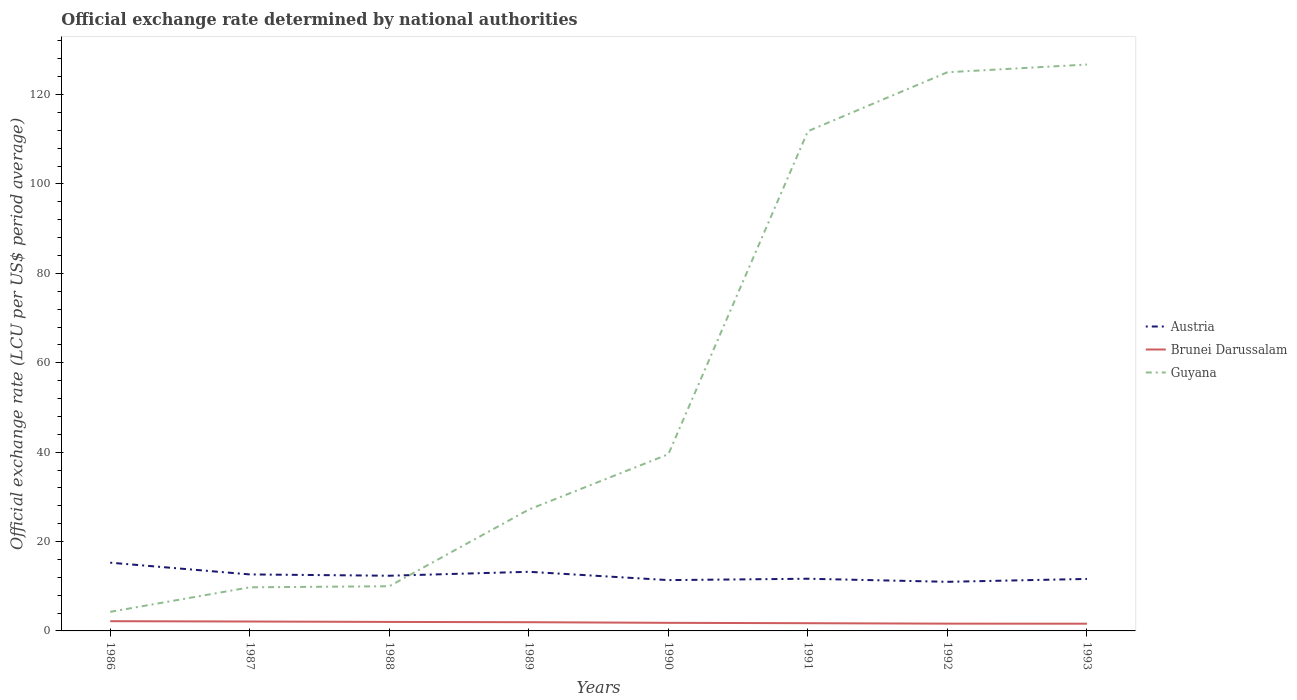Is the number of lines equal to the number of legend labels?
Offer a terse response. Yes. Across all years, what is the maximum official exchange rate in Brunei Darussalam?
Offer a very short reply. 1.62. In which year was the official exchange rate in Austria maximum?
Offer a very short reply. 1992. What is the total official exchange rate in Guyana in the graph?
Offer a very short reply. -14.92. What is the difference between the highest and the second highest official exchange rate in Austria?
Ensure brevity in your answer.  4.28. Is the official exchange rate in Brunei Darussalam strictly greater than the official exchange rate in Guyana over the years?
Offer a terse response. Yes. How many lines are there?
Your answer should be compact. 3. How many years are there in the graph?
Provide a short and direct response. 8. Are the values on the major ticks of Y-axis written in scientific E-notation?
Offer a terse response. No. What is the title of the graph?
Make the answer very short. Official exchange rate determined by national authorities. Does "Senegal" appear as one of the legend labels in the graph?
Offer a very short reply. No. What is the label or title of the X-axis?
Your answer should be compact. Years. What is the label or title of the Y-axis?
Provide a short and direct response. Official exchange rate (LCU per US$ period average). What is the Official exchange rate (LCU per US$ period average) in Austria in 1986?
Your answer should be very brief. 15.27. What is the Official exchange rate (LCU per US$ period average) of Brunei Darussalam in 1986?
Your answer should be compact. 2.18. What is the Official exchange rate (LCU per US$ period average) of Guyana in 1986?
Offer a terse response. 4.27. What is the Official exchange rate (LCU per US$ period average) in Austria in 1987?
Offer a very short reply. 12.64. What is the Official exchange rate (LCU per US$ period average) of Brunei Darussalam in 1987?
Keep it short and to the point. 2.11. What is the Official exchange rate (LCU per US$ period average) of Guyana in 1987?
Provide a succinct answer. 9.76. What is the Official exchange rate (LCU per US$ period average) in Austria in 1988?
Ensure brevity in your answer.  12.35. What is the Official exchange rate (LCU per US$ period average) of Brunei Darussalam in 1988?
Offer a very short reply. 2.01. What is the Official exchange rate (LCU per US$ period average) of Guyana in 1988?
Keep it short and to the point. 10. What is the Official exchange rate (LCU per US$ period average) in Austria in 1989?
Your answer should be compact. 13.23. What is the Official exchange rate (LCU per US$ period average) in Brunei Darussalam in 1989?
Your answer should be very brief. 1.95. What is the Official exchange rate (LCU per US$ period average) in Guyana in 1989?
Keep it short and to the point. 27.16. What is the Official exchange rate (LCU per US$ period average) of Austria in 1990?
Offer a terse response. 11.37. What is the Official exchange rate (LCU per US$ period average) of Brunei Darussalam in 1990?
Offer a very short reply. 1.81. What is the Official exchange rate (LCU per US$ period average) in Guyana in 1990?
Offer a very short reply. 39.53. What is the Official exchange rate (LCU per US$ period average) of Austria in 1991?
Your answer should be very brief. 11.68. What is the Official exchange rate (LCU per US$ period average) of Brunei Darussalam in 1991?
Give a very brief answer. 1.73. What is the Official exchange rate (LCU per US$ period average) in Guyana in 1991?
Make the answer very short. 111.81. What is the Official exchange rate (LCU per US$ period average) of Austria in 1992?
Ensure brevity in your answer.  10.99. What is the Official exchange rate (LCU per US$ period average) of Brunei Darussalam in 1992?
Offer a very short reply. 1.63. What is the Official exchange rate (LCU per US$ period average) in Guyana in 1992?
Offer a terse response. 125. What is the Official exchange rate (LCU per US$ period average) of Austria in 1993?
Make the answer very short. 11.63. What is the Official exchange rate (LCU per US$ period average) in Brunei Darussalam in 1993?
Keep it short and to the point. 1.62. What is the Official exchange rate (LCU per US$ period average) of Guyana in 1993?
Your answer should be compact. 126.73. Across all years, what is the maximum Official exchange rate (LCU per US$ period average) of Austria?
Offer a terse response. 15.27. Across all years, what is the maximum Official exchange rate (LCU per US$ period average) in Brunei Darussalam?
Give a very brief answer. 2.18. Across all years, what is the maximum Official exchange rate (LCU per US$ period average) of Guyana?
Offer a very short reply. 126.73. Across all years, what is the minimum Official exchange rate (LCU per US$ period average) in Austria?
Provide a short and direct response. 10.99. Across all years, what is the minimum Official exchange rate (LCU per US$ period average) in Brunei Darussalam?
Your answer should be very brief. 1.62. Across all years, what is the minimum Official exchange rate (LCU per US$ period average) of Guyana?
Keep it short and to the point. 4.27. What is the total Official exchange rate (LCU per US$ period average) in Austria in the graph?
Ensure brevity in your answer.  99.16. What is the total Official exchange rate (LCU per US$ period average) of Brunei Darussalam in the graph?
Provide a succinct answer. 15.03. What is the total Official exchange rate (LCU per US$ period average) in Guyana in the graph?
Offer a terse response. 454.26. What is the difference between the Official exchange rate (LCU per US$ period average) of Austria in 1986 and that in 1987?
Give a very brief answer. 2.62. What is the difference between the Official exchange rate (LCU per US$ period average) in Brunei Darussalam in 1986 and that in 1987?
Give a very brief answer. 0.07. What is the difference between the Official exchange rate (LCU per US$ period average) of Guyana in 1986 and that in 1987?
Provide a short and direct response. -5.48. What is the difference between the Official exchange rate (LCU per US$ period average) in Austria in 1986 and that in 1988?
Offer a very short reply. 2.92. What is the difference between the Official exchange rate (LCU per US$ period average) of Brunei Darussalam in 1986 and that in 1988?
Provide a short and direct response. 0.17. What is the difference between the Official exchange rate (LCU per US$ period average) of Guyana in 1986 and that in 1988?
Ensure brevity in your answer.  -5.73. What is the difference between the Official exchange rate (LCU per US$ period average) of Austria in 1986 and that in 1989?
Give a very brief answer. 2.04. What is the difference between the Official exchange rate (LCU per US$ period average) in Brunei Darussalam in 1986 and that in 1989?
Offer a very short reply. 0.23. What is the difference between the Official exchange rate (LCU per US$ period average) in Guyana in 1986 and that in 1989?
Ensure brevity in your answer.  -22.89. What is the difference between the Official exchange rate (LCU per US$ period average) of Austria in 1986 and that in 1990?
Your answer should be compact. 3.9. What is the difference between the Official exchange rate (LCU per US$ period average) of Brunei Darussalam in 1986 and that in 1990?
Provide a succinct answer. 0.36. What is the difference between the Official exchange rate (LCU per US$ period average) of Guyana in 1986 and that in 1990?
Provide a short and direct response. -35.26. What is the difference between the Official exchange rate (LCU per US$ period average) in Austria in 1986 and that in 1991?
Your response must be concise. 3.59. What is the difference between the Official exchange rate (LCU per US$ period average) in Brunei Darussalam in 1986 and that in 1991?
Offer a very short reply. 0.45. What is the difference between the Official exchange rate (LCU per US$ period average) in Guyana in 1986 and that in 1991?
Keep it short and to the point. -107.54. What is the difference between the Official exchange rate (LCU per US$ period average) of Austria in 1986 and that in 1992?
Offer a terse response. 4.28. What is the difference between the Official exchange rate (LCU per US$ period average) in Brunei Darussalam in 1986 and that in 1992?
Ensure brevity in your answer.  0.55. What is the difference between the Official exchange rate (LCU per US$ period average) in Guyana in 1986 and that in 1992?
Your response must be concise. -120.73. What is the difference between the Official exchange rate (LCU per US$ period average) in Austria in 1986 and that in 1993?
Offer a terse response. 3.63. What is the difference between the Official exchange rate (LCU per US$ period average) in Brunei Darussalam in 1986 and that in 1993?
Offer a terse response. 0.56. What is the difference between the Official exchange rate (LCU per US$ period average) in Guyana in 1986 and that in 1993?
Your response must be concise. -122.46. What is the difference between the Official exchange rate (LCU per US$ period average) in Austria in 1987 and that in 1988?
Provide a succinct answer. 0.29. What is the difference between the Official exchange rate (LCU per US$ period average) of Brunei Darussalam in 1987 and that in 1988?
Provide a short and direct response. 0.09. What is the difference between the Official exchange rate (LCU per US$ period average) in Guyana in 1987 and that in 1988?
Offer a terse response. -0.24. What is the difference between the Official exchange rate (LCU per US$ period average) of Austria in 1987 and that in 1989?
Ensure brevity in your answer.  -0.59. What is the difference between the Official exchange rate (LCU per US$ period average) of Brunei Darussalam in 1987 and that in 1989?
Your answer should be compact. 0.16. What is the difference between the Official exchange rate (LCU per US$ period average) in Guyana in 1987 and that in 1989?
Your answer should be very brief. -17.4. What is the difference between the Official exchange rate (LCU per US$ period average) of Austria in 1987 and that in 1990?
Make the answer very short. 1.27. What is the difference between the Official exchange rate (LCU per US$ period average) in Brunei Darussalam in 1987 and that in 1990?
Give a very brief answer. 0.29. What is the difference between the Official exchange rate (LCU per US$ period average) in Guyana in 1987 and that in 1990?
Offer a terse response. -29.78. What is the difference between the Official exchange rate (LCU per US$ period average) of Austria in 1987 and that in 1991?
Ensure brevity in your answer.  0.97. What is the difference between the Official exchange rate (LCU per US$ period average) in Brunei Darussalam in 1987 and that in 1991?
Your answer should be compact. 0.38. What is the difference between the Official exchange rate (LCU per US$ period average) in Guyana in 1987 and that in 1991?
Your answer should be very brief. -102.05. What is the difference between the Official exchange rate (LCU per US$ period average) of Austria in 1987 and that in 1992?
Provide a succinct answer. 1.65. What is the difference between the Official exchange rate (LCU per US$ period average) in Brunei Darussalam in 1987 and that in 1992?
Offer a terse response. 0.48. What is the difference between the Official exchange rate (LCU per US$ period average) in Guyana in 1987 and that in 1992?
Ensure brevity in your answer.  -115.25. What is the difference between the Official exchange rate (LCU per US$ period average) in Austria in 1987 and that in 1993?
Provide a succinct answer. 1.01. What is the difference between the Official exchange rate (LCU per US$ period average) of Brunei Darussalam in 1987 and that in 1993?
Give a very brief answer. 0.49. What is the difference between the Official exchange rate (LCU per US$ period average) of Guyana in 1987 and that in 1993?
Offer a terse response. -116.97. What is the difference between the Official exchange rate (LCU per US$ period average) of Austria in 1988 and that in 1989?
Offer a very short reply. -0.88. What is the difference between the Official exchange rate (LCU per US$ period average) of Brunei Darussalam in 1988 and that in 1989?
Your answer should be compact. 0.06. What is the difference between the Official exchange rate (LCU per US$ period average) of Guyana in 1988 and that in 1989?
Offer a very short reply. -17.16. What is the difference between the Official exchange rate (LCU per US$ period average) of Austria in 1988 and that in 1990?
Your answer should be compact. 0.98. What is the difference between the Official exchange rate (LCU per US$ period average) of Brunei Darussalam in 1988 and that in 1990?
Offer a very short reply. 0.2. What is the difference between the Official exchange rate (LCU per US$ period average) of Guyana in 1988 and that in 1990?
Provide a succinct answer. -29.53. What is the difference between the Official exchange rate (LCU per US$ period average) in Austria in 1988 and that in 1991?
Your response must be concise. 0.67. What is the difference between the Official exchange rate (LCU per US$ period average) in Brunei Darussalam in 1988 and that in 1991?
Your answer should be compact. 0.28. What is the difference between the Official exchange rate (LCU per US$ period average) in Guyana in 1988 and that in 1991?
Make the answer very short. -101.81. What is the difference between the Official exchange rate (LCU per US$ period average) in Austria in 1988 and that in 1992?
Your answer should be very brief. 1.36. What is the difference between the Official exchange rate (LCU per US$ period average) in Brunei Darussalam in 1988 and that in 1992?
Your response must be concise. 0.38. What is the difference between the Official exchange rate (LCU per US$ period average) in Guyana in 1988 and that in 1992?
Give a very brief answer. -115. What is the difference between the Official exchange rate (LCU per US$ period average) in Austria in 1988 and that in 1993?
Keep it short and to the point. 0.72. What is the difference between the Official exchange rate (LCU per US$ period average) in Brunei Darussalam in 1988 and that in 1993?
Make the answer very short. 0.4. What is the difference between the Official exchange rate (LCU per US$ period average) of Guyana in 1988 and that in 1993?
Provide a short and direct response. -116.73. What is the difference between the Official exchange rate (LCU per US$ period average) in Austria in 1989 and that in 1990?
Your answer should be compact. 1.86. What is the difference between the Official exchange rate (LCU per US$ period average) in Brunei Darussalam in 1989 and that in 1990?
Provide a short and direct response. 0.14. What is the difference between the Official exchange rate (LCU per US$ period average) of Guyana in 1989 and that in 1990?
Keep it short and to the point. -12.37. What is the difference between the Official exchange rate (LCU per US$ period average) in Austria in 1989 and that in 1991?
Keep it short and to the point. 1.55. What is the difference between the Official exchange rate (LCU per US$ period average) of Brunei Darussalam in 1989 and that in 1991?
Make the answer very short. 0.22. What is the difference between the Official exchange rate (LCU per US$ period average) in Guyana in 1989 and that in 1991?
Offer a terse response. -84.65. What is the difference between the Official exchange rate (LCU per US$ period average) in Austria in 1989 and that in 1992?
Your response must be concise. 2.24. What is the difference between the Official exchange rate (LCU per US$ period average) of Brunei Darussalam in 1989 and that in 1992?
Keep it short and to the point. 0.32. What is the difference between the Official exchange rate (LCU per US$ period average) of Guyana in 1989 and that in 1992?
Your answer should be very brief. -97.84. What is the difference between the Official exchange rate (LCU per US$ period average) of Austria in 1989 and that in 1993?
Offer a very short reply. 1.6. What is the difference between the Official exchange rate (LCU per US$ period average) in Brunei Darussalam in 1989 and that in 1993?
Ensure brevity in your answer.  0.33. What is the difference between the Official exchange rate (LCU per US$ period average) of Guyana in 1989 and that in 1993?
Your answer should be compact. -99.57. What is the difference between the Official exchange rate (LCU per US$ period average) in Austria in 1990 and that in 1991?
Provide a succinct answer. -0.31. What is the difference between the Official exchange rate (LCU per US$ period average) of Brunei Darussalam in 1990 and that in 1991?
Your answer should be very brief. 0.09. What is the difference between the Official exchange rate (LCU per US$ period average) in Guyana in 1990 and that in 1991?
Offer a very short reply. -72.28. What is the difference between the Official exchange rate (LCU per US$ period average) of Austria in 1990 and that in 1992?
Your response must be concise. 0.38. What is the difference between the Official exchange rate (LCU per US$ period average) in Brunei Darussalam in 1990 and that in 1992?
Provide a short and direct response. 0.18. What is the difference between the Official exchange rate (LCU per US$ period average) in Guyana in 1990 and that in 1992?
Offer a very short reply. -85.47. What is the difference between the Official exchange rate (LCU per US$ period average) in Austria in 1990 and that in 1993?
Your answer should be very brief. -0.26. What is the difference between the Official exchange rate (LCU per US$ period average) in Brunei Darussalam in 1990 and that in 1993?
Give a very brief answer. 0.2. What is the difference between the Official exchange rate (LCU per US$ period average) in Guyana in 1990 and that in 1993?
Offer a very short reply. -87.2. What is the difference between the Official exchange rate (LCU per US$ period average) in Austria in 1991 and that in 1992?
Your answer should be very brief. 0.69. What is the difference between the Official exchange rate (LCU per US$ period average) of Brunei Darussalam in 1991 and that in 1992?
Keep it short and to the point. 0.1. What is the difference between the Official exchange rate (LCU per US$ period average) in Guyana in 1991 and that in 1992?
Your answer should be compact. -13.19. What is the difference between the Official exchange rate (LCU per US$ period average) in Austria in 1991 and that in 1993?
Ensure brevity in your answer.  0.04. What is the difference between the Official exchange rate (LCU per US$ period average) of Brunei Darussalam in 1991 and that in 1993?
Ensure brevity in your answer.  0.11. What is the difference between the Official exchange rate (LCU per US$ period average) in Guyana in 1991 and that in 1993?
Make the answer very short. -14.92. What is the difference between the Official exchange rate (LCU per US$ period average) in Austria in 1992 and that in 1993?
Your answer should be compact. -0.64. What is the difference between the Official exchange rate (LCU per US$ period average) in Brunei Darussalam in 1992 and that in 1993?
Give a very brief answer. 0.01. What is the difference between the Official exchange rate (LCU per US$ period average) of Guyana in 1992 and that in 1993?
Provide a short and direct response. -1.73. What is the difference between the Official exchange rate (LCU per US$ period average) of Austria in 1986 and the Official exchange rate (LCU per US$ period average) of Brunei Darussalam in 1987?
Your answer should be compact. 13.16. What is the difference between the Official exchange rate (LCU per US$ period average) of Austria in 1986 and the Official exchange rate (LCU per US$ period average) of Guyana in 1987?
Ensure brevity in your answer.  5.51. What is the difference between the Official exchange rate (LCU per US$ period average) in Brunei Darussalam in 1986 and the Official exchange rate (LCU per US$ period average) in Guyana in 1987?
Your answer should be very brief. -7.58. What is the difference between the Official exchange rate (LCU per US$ period average) in Austria in 1986 and the Official exchange rate (LCU per US$ period average) in Brunei Darussalam in 1988?
Keep it short and to the point. 13.25. What is the difference between the Official exchange rate (LCU per US$ period average) of Austria in 1986 and the Official exchange rate (LCU per US$ period average) of Guyana in 1988?
Your answer should be compact. 5.27. What is the difference between the Official exchange rate (LCU per US$ period average) of Brunei Darussalam in 1986 and the Official exchange rate (LCU per US$ period average) of Guyana in 1988?
Your response must be concise. -7.82. What is the difference between the Official exchange rate (LCU per US$ period average) in Austria in 1986 and the Official exchange rate (LCU per US$ period average) in Brunei Darussalam in 1989?
Provide a short and direct response. 13.32. What is the difference between the Official exchange rate (LCU per US$ period average) in Austria in 1986 and the Official exchange rate (LCU per US$ period average) in Guyana in 1989?
Provide a short and direct response. -11.89. What is the difference between the Official exchange rate (LCU per US$ period average) in Brunei Darussalam in 1986 and the Official exchange rate (LCU per US$ period average) in Guyana in 1989?
Offer a very short reply. -24.98. What is the difference between the Official exchange rate (LCU per US$ period average) in Austria in 1986 and the Official exchange rate (LCU per US$ period average) in Brunei Darussalam in 1990?
Provide a succinct answer. 13.45. What is the difference between the Official exchange rate (LCU per US$ period average) in Austria in 1986 and the Official exchange rate (LCU per US$ period average) in Guyana in 1990?
Ensure brevity in your answer.  -24.27. What is the difference between the Official exchange rate (LCU per US$ period average) of Brunei Darussalam in 1986 and the Official exchange rate (LCU per US$ period average) of Guyana in 1990?
Provide a succinct answer. -37.36. What is the difference between the Official exchange rate (LCU per US$ period average) in Austria in 1986 and the Official exchange rate (LCU per US$ period average) in Brunei Darussalam in 1991?
Offer a terse response. 13.54. What is the difference between the Official exchange rate (LCU per US$ period average) in Austria in 1986 and the Official exchange rate (LCU per US$ period average) in Guyana in 1991?
Offer a very short reply. -96.54. What is the difference between the Official exchange rate (LCU per US$ period average) in Brunei Darussalam in 1986 and the Official exchange rate (LCU per US$ period average) in Guyana in 1991?
Give a very brief answer. -109.63. What is the difference between the Official exchange rate (LCU per US$ period average) of Austria in 1986 and the Official exchange rate (LCU per US$ period average) of Brunei Darussalam in 1992?
Your response must be concise. 13.64. What is the difference between the Official exchange rate (LCU per US$ period average) of Austria in 1986 and the Official exchange rate (LCU per US$ period average) of Guyana in 1992?
Make the answer very short. -109.74. What is the difference between the Official exchange rate (LCU per US$ period average) of Brunei Darussalam in 1986 and the Official exchange rate (LCU per US$ period average) of Guyana in 1992?
Keep it short and to the point. -122.83. What is the difference between the Official exchange rate (LCU per US$ period average) in Austria in 1986 and the Official exchange rate (LCU per US$ period average) in Brunei Darussalam in 1993?
Provide a short and direct response. 13.65. What is the difference between the Official exchange rate (LCU per US$ period average) in Austria in 1986 and the Official exchange rate (LCU per US$ period average) in Guyana in 1993?
Keep it short and to the point. -111.46. What is the difference between the Official exchange rate (LCU per US$ period average) in Brunei Darussalam in 1986 and the Official exchange rate (LCU per US$ period average) in Guyana in 1993?
Keep it short and to the point. -124.55. What is the difference between the Official exchange rate (LCU per US$ period average) in Austria in 1987 and the Official exchange rate (LCU per US$ period average) in Brunei Darussalam in 1988?
Give a very brief answer. 10.63. What is the difference between the Official exchange rate (LCU per US$ period average) in Austria in 1987 and the Official exchange rate (LCU per US$ period average) in Guyana in 1988?
Your response must be concise. 2.64. What is the difference between the Official exchange rate (LCU per US$ period average) in Brunei Darussalam in 1987 and the Official exchange rate (LCU per US$ period average) in Guyana in 1988?
Your response must be concise. -7.89. What is the difference between the Official exchange rate (LCU per US$ period average) of Austria in 1987 and the Official exchange rate (LCU per US$ period average) of Brunei Darussalam in 1989?
Give a very brief answer. 10.69. What is the difference between the Official exchange rate (LCU per US$ period average) in Austria in 1987 and the Official exchange rate (LCU per US$ period average) in Guyana in 1989?
Provide a succinct answer. -14.52. What is the difference between the Official exchange rate (LCU per US$ period average) in Brunei Darussalam in 1987 and the Official exchange rate (LCU per US$ period average) in Guyana in 1989?
Ensure brevity in your answer.  -25.05. What is the difference between the Official exchange rate (LCU per US$ period average) of Austria in 1987 and the Official exchange rate (LCU per US$ period average) of Brunei Darussalam in 1990?
Your answer should be compact. 10.83. What is the difference between the Official exchange rate (LCU per US$ period average) of Austria in 1987 and the Official exchange rate (LCU per US$ period average) of Guyana in 1990?
Offer a very short reply. -26.89. What is the difference between the Official exchange rate (LCU per US$ period average) in Brunei Darussalam in 1987 and the Official exchange rate (LCU per US$ period average) in Guyana in 1990?
Provide a short and direct response. -37.43. What is the difference between the Official exchange rate (LCU per US$ period average) in Austria in 1987 and the Official exchange rate (LCU per US$ period average) in Brunei Darussalam in 1991?
Provide a short and direct response. 10.91. What is the difference between the Official exchange rate (LCU per US$ period average) of Austria in 1987 and the Official exchange rate (LCU per US$ period average) of Guyana in 1991?
Offer a very short reply. -99.17. What is the difference between the Official exchange rate (LCU per US$ period average) of Brunei Darussalam in 1987 and the Official exchange rate (LCU per US$ period average) of Guyana in 1991?
Your response must be concise. -109.7. What is the difference between the Official exchange rate (LCU per US$ period average) in Austria in 1987 and the Official exchange rate (LCU per US$ period average) in Brunei Darussalam in 1992?
Provide a short and direct response. 11.01. What is the difference between the Official exchange rate (LCU per US$ period average) in Austria in 1987 and the Official exchange rate (LCU per US$ period average) in Guyana in 1992?
Offer a terse response. -112.36. What is the difference between the Official exchange rate (LCU per US$ period average) in Brunei Darussalam in 1987 and the Official exchange rate (LCU per US$ period average) in Guyana in 1992?
Your response must be concise. -122.9. What is the difference between the Official exchange rate (LCU per US$ period average) of Austria in 1987 and the Official exchange rate (LCU per US$ period average) of Brunei Darussalam in 1993?
Offer a very short reply. 11.03. What is the difference between the Official exchange rate (LCU per US$ period average) in Austria in 1987 and the Official exchange rate (LCU per US$ period average) in Guyana in 1993?
Provide a succinct answer. -114.09. What is the difference between the Official exchange rate (LCU per US$ period average) of Brunei Darussalam in 1987 and the Official exchange rate (LCU per US$ period average) of Guyana in 1993?
Offer a very short reply. -124.62. What is the difference between the Official exchange rate (LCU per US$ period average) of Austria in 1988 and the Official exchange rate (LCU per US$ period average) of Brunei Darussalam in 1989?
Provide a succinct answer. 10.4. What is the difference between the Official exchange rate (LCU per US$ period average) of Austria in 1988 and the Official exchange rate (LCU per US$ period average) of Guyana in 1989?
Keep it short and to the point. -14.81. What is the difference between the Official exchange rate (LCU per US$ period average) in Brunei Darussalam in 1988 and the Official exchange rate (LCU per US$ period average) in Guyana in 1989?
Provide a succinct answer. -25.15. What is the difference between the Official exchange rate (LCU per US$ period average) in Austria in 1988 and the Official exchange rate (LCU per US$ period average) in Brunei Darussalam in 1990?
Keep it short and to the point. 10.54. What is the difference between the Official exchange rate (LCU per US$ period average) of Austria in 1988 and the Official exchange rate (LCU per US$ period average) of Guyana in 1990?
Provide a succinct answer. -27.19. What is the difference between the Official exchange rate (LCU per US$ period average) of Brunei Darussalam in 1988 and the Official exchange rate (LCU per US$ period average) of Guyana in 1990?
Your answer should be compact. -37.52. What is the difference between the Official exchange rate (LCU per US$ period average) of Austria in 1988 and the Official exchange rate (LCU per US$ period average) of Brunei Darussalam in 1991?
Make the answer very short. 10.62. What is the difference between the Official exchange rate (LCU per US$ period average) in Austria in 1988 and the Official exchange rate (LCU per US$ period average) in Guyana in 1991?
Give a very brief answer. -99.46. What is the difference between the Official exchange rate (LCU per US$ period average) in Brunei Darussalam in 1988 and the Official exchange rate (LCU per US$ period average) in Guyana in 1991?
Offer a terse response. -109.8. What is the difference between the Official exchange rate (LCU per US$ period average) in Austria in 1988 and the Official exchange rate (LCU per US$ period average) in Brunei Darussalam in 1992?
Provide a succinct answer. 10.72. What is the difference between the Official exchange rate (LCU per US$ period average) in Austria in 1988 and the Official exchange rate (LCU per US$ period average) in Guyana in 1992?
Your response must be concise. -112.65. What is the difference between the Official exchange rate (LCU per US$ period average) of Brunei Darussalam in 1988 and the Official exchange rate (LCU per US$ period average) of Guyana in 1992?
Keep it short and to the point. -122.99. What is the difference between the Official exchange rate (LCU per US$ period average) in Austria in 1988 and the Official exchange rate (LCU per US$ period average) in Brunei Darussalam in 1993?
Your answer should be compact. 10.73. What is the difference between the Official exchange rate (LCU per US$ period average) in Austria in 1988 and the Official exchange rate (LCU per US$ period average) in Guyana in 1993?
Ensure brevity in your answer.  -114.38. What is the difference between the Official exchange rate (LCU per US$ period average) in Brunei Darussalam in 1988 and the Official exchange rate (LCU per US$ period average) in Guyana in 1993?
Give a very brief answer. -124.72. What is the difference between the Official exchange rate (LCU per US$ period average) in Austria in 1989 and the Official exchange rate (LCU per US$ period average) in Brunei Darussalam in 1990?
Your answer should be compact. 11.42. What is the difference between the Official exchange rate (LCU per US$ period average) in Austria in 1989 and the Official exchange rate (LCU per US$ period average) in Guyana in 1990?
Your answer should be compact. -26.3. What is the difference between the Official exchange rate (LCU per US$ period average) of Brunei Darussalam in 1989 and the Official exchange rate (LCU per US$ period average) of Guyana in 1990?
Make the answer very short. -37.58. What is the difference between the Official exchange rate (LCU per US$ period average) of Austria in 1989 and the Official exchange rate (LCU per US$ period average) of Brunei Darussalam in 1991?
Keep it short and to the point. 11.5. What is the difference between the Official exchange rate (LCU per US$ period average) in Austria in 1989 and the Official exchange rate (LCU per US$ period average) in Guyana in 1991?
Your answer should be very brief. -98.58. What is the difference between the Official exchange rate (LCU per US$ period average) of Brunei Darussalam in 1989 and the Official exchange rate (LCU per US$ period average) of Guyana in 1991?
Offer a very short reply. -109.86. What is the difference between the Official exchange rate (LCU per US$ period average) of Austria in 1989 and the Official exchange rate (LCU per US$ period average) of Brunei Darussalam in 1992?
Your answer should be compact. 11.6. What is the difference between the Official exchange rate (LCU per US$ period average) in Austria in 1989 and the Official exchange rate (LCU per US$ period average) in Guyana in 1992?
Offer a very short reply. -111.77. What is the difference between the Official exchange rate (LCU per US$ period average) in Brunei Darussalam in 1989 and the Official exchange rate (LCU per US$ period average) in Guyana in 1992?
Your response must be concise. -123.05. What is the difference between the Official exchange rate (LCU per US$ period average) of Austria in 1989 and the Official exchange rate (LCU per US$ period average) of Brunei Darussalam in 1993?
Keep it short and to the point. 11.61. What is the difference between the Official exchange rate (LCU per US$ period average) of Austria in 1989 and the Official exchange rate (LCU per US$ period average) of Guyana in 1993?
Ensure brevity in your answer.  -113.5. What is the difference between the Official exchange rate (LCU per US$ period average) in Brunei Darussalam in 1989 and the Official exchange rate (LCU per US$ period average) in Guyana in 1993?
Provide a short and direct response. -124.78. What is the difference between the Official exchange rate (LCU per US$ period average) in Austria in 1990 and the Official exchange rate (LCU per US$ period average) in Brunei Darussalam in 1991?
Keep it short and to the point. 9.64. What is the difference between the Official exchange rate (LCU per US$ period average) of Austria in 1990 and the Official exchange rate (LCU per US$ period average) of Guyana in 1991?
Your response must be concise. -100.44. What is the difference between the Official exchange rate (LCU per US$ period average) in Brunei Darussalam in 1990 and the Official exchange rate (LCU per US$ period average) in Guyana in 1991?
Offer a terse response. -110. What is the difference between the Official exchange rate (LCU per US$ period average) of Austria in 1990 and the Official exchange rate (LCU per US$ period average) of Brunei Darussalam in 1992?
Provide a short and direct response. 9.74. What is the difference between the Official exchange rate (LCU per US$ period average) of Austria in 1990 and the Official exchange rate (LCU per US$ period average) of Guyana in 1992?
Your response must be concise. -113.63. What is the difference between the Official exchange rate (LCU per US$ period average) of Brunei Darussalam in 1990 and the Official exchange rate (LCU per US$ period average) of Guyana in 1992?
Your response must be concise. -123.19. What is the difference between the Official exchange rate (LCU per US$ period average) of Austria in 1990 and the Official exchange rate (LCU per US$ period average) of Brunei Darussalam in 1993?
Ensure brevity in your answer.  9.75. What is the difference between the Official exchange rate (LCU per US$ period average) in Austria in 1990 and the Official exchange rate (LCU per US$ period average) in Guyana in 1993?
Offer a very short reply. -115.36. What is the difference between the Official exchange rate (LCU per US$ period average) of Brunei Darussalam in 1990 and the Official exchange rate (LCU per US$ period average) of Guyana in 1993?
Ensure brevity in your answer.  -124.92. What is the difference between the Official exchange rate (LCU per US$ period average) in Austria in 1991 and the Official exchange rate (LCU per US$ period average) in Brunei Darussalam in 1992?
Provide a short and direct response. 10.05. What is the difference between the Official exchange rate (LCU per US$ period average) of Austria in 1991 and the Official exchange rate (LCU per US$ period average) of Guyana in 1992?
Provide a short and direct response. -113.33. What is the difference between the Official exchange rate (LCU per US$ period average) in Brunei Darussalam in 1991 and the Official exchange rate (LCU per US$ period average) in Guyana in 1992?
Your answer should be very brief. -123.28. What is the difference between the Official exchange rate (LCU per US$ period average) of Austria in 1991 and the Official exchange rate (LCU per US$ period average) of Brunei Darussalam in 1993?
Give a very brief answer. 10.06. What is the difference between the Official exchange rate (LCU per US$ period average) in Austria in 1991 and the Official exchange rate (LCU per US$ period average) in Guyana in 1993?
Ensure brevity in your answer.  -115.05. What is the difference between the Official exchange rate (LCU per US$ period average) in Brunei Darussalam in 1991 and the Official exchange rate (LCU per US$ period average) in Guyana in 1993?
Your answer should be very brief. -125. What is the difference between the Official exchange rate (LCU per US$ period average) in Austria in 1992 and the Official exchange rate (LCU per US$ period average) in Brunei Darussalam in 1993?
Offer a very short reply. 9.37. What is the difference between the Official exchange rate (LCU per US$ period average) in Austria in 1992 and the Official exchange rate (LCU per US$ period average) in Guyana in 1993?
Your answer should be compact. -115.74. What is the difference between the Official exchange rate (LCU per US$ period average) in Brunei Darussalam in 1992 and the Official exchange rate (LCU per US$ period average) in Guyana in 1993?
Your answer should be very brief. -125.1. What is the average Official exchange rate (LCU per US$ period average) of Austria per year?
Offer a terse response. 12.39. What is the average Official exchange rate (LCU per US$ period average) in Brunei Darussalam per year?
Your answer should be compact. 1.88. What is the average Official exchange rate (LCU per US$ period average) in Guyana per year?
Your answer should be very brief. 56.78. In the year 1986, what is the difference between the Official exchange rate (LCU per US$ period average) of Austria and Official exchange rate (LCU per US$ period average) of Brunei Darussalam?
Offer a very short reply. 13.09. In the year 1986, what is the difference between the Official exchange rate (LCU per US$ period average) of Austria and Official exchange rate (LCU per US$ period average) of Guyana?
Offer a very short reply. 10.99. In the year 1986, what is the difference between the Official exchange rate (LCU per US$ period average) of Brunei Darussalam and Official exchange rate (LCU per US$ period average) of Guyana?
Offer a terse response. -2.1. In the year 1987, what is the difference between the Official exchange rate (LCU per US$ period average) in Austria and Official exchange rate (LCU per US$ period average) in Brunei Darussalam?
Ensure brevity in your answer.  10.54. In the year 1987, what is the difference between the Official exchange rate (LCU per US$ period average) of Austria and Official exchange rate (LCU per US$ period average) of Guyana?
Your response must be concise. 2.89. In the year 1987, what is the difference between the Official exchange rate (LCU per US$ period average) in Brunei Darussalam and Official exchange rate (LCU per US$ period average) in Guyana?
Provide a short and direct response. -7.65. In the year 1988, what is the difference between the Official exchange rate (LCU per US$ period average) in Austria and Official exchange rate (LCU per US$ period average) in Brunei Darussalam?
Offer a very short reply. 10.34. In the year 1988, what is the difference between the Official exchange rate (LCU per US$ period average) in Austria and Official exchange rate (LCU per US$ period average) in Guyana?
Make the answer very short. 2.35. In the year 1988, what is the difference between the Official exchange rate (LCU per US$ period average) of Brunei Darussalam and Official exchange rate (LCU per US$ period average) of Guyana?
Provide a succinct answer. -7.99. In the year 1989, what is the difference between the Official exchange rate (LCU per US$ period average) in Austria and Official exchange rate (LCU per US$ period average) in Brunei Darussalam?
Your answer should be compact. 11.28. In the year 1989, what is the difference between the Official exchange rate (LCU per US$ period average) in Austria and Official exchange rate (LCU per US$ period average) in Guyana?
Give a very brief answer. -13.93. In the year 1989, what is the difference between the Official exchange rate (LCU per US$ period average) of Brunei Darussalam and Official exchange rate (LCU per US$ period average) of Guyana?
Offer a very short reply. -25.21. In the year 1990, what is the difference between the Official exchange rate (LCU per US$ period average) in Austria and Official exchange rate (LCU per US$ period average) in Brunei Darussalam?
Your answer should be very brief. 9.56. In the year 1990, what is the difference between the Official exchange rate (LCU per US$ period average) in Austria and Official exchange rate (LCU per US$ period average) in Guyana?
Provide a succinct answer. -28.16. In the year 1990, what is the difference between the Official exchange rate (LCU per US$ period average) of Brunei Darussalam and Official exchange rate (LCU per US$ period average) of Guyana?
Your answer should be very brief. -37.72. In the year 1991, what is the difference between the Official exchange rate (LCU per US$ period average) of Austria and Official exchange rate (LCU per US$ period average) of Brunei Darussalam?
Your response must be concise. 9.95. In the year 1991, what is the difference between the Official exchange rate (LCU per US$ period average) of Austria and Official exchange rate (LCU per US$ period average) of Guyana?
Ensure brevity in your answer.  -100.13. In the year 1991, what is the difference between the Official exchange rate (LCU per US$ period average) in Brunei Darussalam and Official exchange rate (LCU per US$ period average) in Guyana?
Your answer should be compact. -110.08. In the year 1992, what is the difference between the Official exchange rate (LCU per US$ period average) in Austria and Official exchange rate (LCU per US$ period average) in Brunei Darussalam?
Keep it short and to the point. 9.36. In the year 1992, what is the difference between the Official exchange rate (LCU per US$ period average) in Austria and Official exchange rate (LCU per US$ period average) in Guyana?
Your answer should be very brief. -114.01. In the year 1992, what is the difference between the Official exchange rate (LCU per US$ period average) of Brunei Darussalam and Official exchange rate (LCU per US$ period average) of Guyana?
Your answer should be compact. -123.37. In the year 1993, what is the difference between the Official exchange rate (LCU per US$ period average) in Austria and Official exchange rate (LCU per US$ period average) in Brunei Darussalam?
Your answer should be very brief. 10.02. In the year 1993, what is the difference between the Official exchange rate (LCU per US$ period average) of Austria and Official exchange rate (LCU per US$ period average) of Guyana?
Your answer should be compact. -115.1. In the year 1993, what is the difference between the Official exchange rate (LCU per US$ period average) in Brunei Darussalam and Official exchange rate (LCU per US$ period average) in Guyana?
Your response must be concise. -125.11. What is the ratio of the Official exchange rate (LCU per US$ period average) in Austria in 1986 to that in 1987?
Ensure brevity in your answer.  1.21. What is the ratio of the Official exchange rate (LCU per US$ period average) of Brunei Darussalam in 1986 to that in 1987?
Ensure brevity in your answer.  1.03. What is the ratio of the Official exchange rate (LCU per US$ period average) in Guyana in 1986 to that in 1987?
Give a very brief answer. 0.44. What is the ratio of the Official exchange rate (LCU per US$ period average) of Austria in 1986 to that in 1988?
Ensure brevity in your answer.  1.24. What is the ratio of the Official exchange rate (LCU per US$ period average) in Brunei Darussalam in 1986 to that in 1988?
Ensure brevity in your answer.  1.08. What is the ratio of the Official exchange rate (LCU per US$ period average) in Guyana in 1986 to that in 1988?
Give a very brief answer. 0.43. What is the ratio of the Official exchange rate (LCU per US$ period average) in Austria in 1986 to that in 1989?
Give a very brief answer. 1.15. What is the ratio of the Official exchange rate (LCU per US$ period average) in Brunei Darussalam in 1986 to that in 1989?
Your answer should be very brief. 1.12. What is the ratio of the Official exchange rate (LCU per US$ period average) of Guyana in 1986 to that in 1989?
Your answer should be very brief. 0.16. What is the ratio of the Official exchange rate (LCU per US$ period average) in Austria in 1986 to that in 1990?
Ensure brevity in your answer.  1.34. What is the ratio of the Official exchange rate (LCU per US$ period average) of Brunei Darussalam in 1986 to that in 1990?
Offer a terse response. 1.2. What is the ratio of the Official exchange rate (LCU per US$ period average) of Guyana in 1986 to that in 1990?
Your answer should be compact. 0.11. What is the ratio of the Official exchange rate (LCU per US$ period average) of Austria in 1986 to that in 1991?
Provide a short and direct response. 1.31. What is the ratio of the Official exchange rate (LCU per US$ period average) of Brunei Darussalam in 1986 to that in 1991?
Ensure brevity in your answer.  1.26. What is the ratio of the Official exchange rate (LCU per US$ period average) in Guyana in 1986 to that in 1991?
Your answer should be very brief. 0.04. What is the ratio of the Official exchange rate (LCU per US$ period average) in Austria in 1986 to that in 1992?
Your answer should be very brief. 1.39. What is the ratio of the Official exchange rate (LCU per US$ period average) in Brunei Darussalam in 1986 to that in 1992?
Your answer should be compact. 1.34. What is the ratio of the Official exchange rate (LCU per US$ period average) in Guyana in 1986 to that in 1992?
Your answer should be very brief. 0.03. What is the ratio of the Official exchange rate (LCU per US$ period average) of Austria in 1986 to that in 1993?
Ensure brevity in your answer.  1.31. What is the ratio of the Official exchange rate (LCU per US$ period average) of Brunei Darussalam in 1986 to that in 1993?
Give a very brief answer. 1.35. What is the ratio of the Official exchange rate (LCU per US$ period average) of Guyana in 1986 to that in 1993?
Your response must be concise. 0.03. What is the ratio of the Official exchange rate (LCU per US$ period average) of Austria in 1987 to that in 1988?
Your response must be concise. 1.02. What is the ratio of the Official exchange rate (LCU per US$ period average) of Brunei Darussalam in 1987 to that in 1988?
Provide a short and direct response. 1.05. What is the ratio of the Official exchange rate (LCU per US$ period average) in Guyana in 1987 to that in 1988?
Provide a succinct answer. 0.98. What is the ratio of the Official exchange rate (LCU per US$ period average) in Austria in 1987 to that in 1989?
Ensure brevity in your answer.  0.96. What is the ratio of the Official exchange rate (LCU per US$ period average) in Brunei Darussalam in 1987 to that in 1989?
Keep it short and to the point. 1.08. What is the ratio of the Official exchange rate (LCU per US$ period average) of Guyana in 1987 to that in 1989?
Ensure brevity in your answer.  0.36. What is the ratio of the Official exchange rate (LCU per US$ period average) in Austria in 1987 to that in 1990?
Provide a short and direct response. 1.11. What is the ratio of the Official exchange rate (LCU per US$ period average) in Brunei Darussalam in 1987 to that in 1990?
Your answer should be very brief. 1.16. What is the ratio of the Official exchange rate (LCU per US$ period average) of Guyana in 1987 to that in 1990?
Offer a very short reply. 0.25. What is the ratio of the Official exchange rate (LCU per US$ period average) in Austria in 1987 to that in 1991?
Your answer should be compact. 1.08. What is the ratio of the Official exchange rate (LCU per US$ period average) of Brunei Darussalam in 1987 to that in 1991?
Your answer should be very brief. 1.22. What is the ratio of the Official exchange rate (LCU per US$ period average) in Guyana in 1987 to that in 1991?
Offer a terse response. 0.09. What is the ratio of the Official exchange rate (LCU per US$ period average) of Austria in 1987 to that in 1992?
Keep it short and to the point. 1.15. What is the ratio of the Official exchange rate (LCU per US$ period average) in Brunei Darussalam in 1987 to that in 1992?
Your answer should be very brief. 1.29. What is the ratio of the Official exchange rate (LCU per US$ period average) in Guyana in 1987 to that in 1992?
Your answer should be very brief. 0.08. What is the ratio of the Official exchange rate (LCU per US$ period average) in Austria in 1987 to that in 1993?
Offer a terse response. 1.09. What is the ratio of the Official exchange rate (LCU per US$ period average) of Brunei Darussalam in 1987 to that in 1993?
Make the answer very short. 1.3. What is the ratio of the Official exchange rate (LCU per US$ period average) of Guyana in 1987 to that in 1993?
Your response must be concise. 0.08. What is the ratio of the Official exchange rate (LCU per US$ period average) in Austria in 1988 to that in 1989?
Provide a succinct answer. 0.93. What is the ratio of the Official exchange rate (LCU per US$ period average) of Brunei Darussalam in 1988 to that in 1989?
Ensure brevity in your answer.  1.03. What is the ratio of the Official exchange rate (LCU per US$ period average) in Guyana in 1988 to that in 1989?
Give a very brief answer. 0.37. What is the ratio of the Official exchange rate (LCU per US$ period average) in Austria in 1988 to that in 1990?
Your answer should be very brief. 1.09. What is the ratio of the Official exchange rate (LCU per US$ period average) in Brunei Darussalam in 1988 to that in 1990?
Provide a succinct answer. 1.11. What is the ratio of the Official exchange rate (LCU per US$ period average) in Guyana in 1988 to that in 1990?
Provide a succinct answer. 0.25. What is the ratio of the Official exchange rate (LCU per US$ period average) in Austria in 1988 to that in 1991?
Your response must be concise. 1.06. What is the ratio of the Official exchange rate (LCU per US$ period average) in Brunei Darussalam in 1988 to that in 1991?
Provide a succinct answer. 1.16. What is the ratio of the Official exchange rate (LCU per US$ period average) of Guyana in 1988 to that in 1991?
Your answer should be very brief. 0.09. What is the ratio of the Official exchange rate (LCU per US$ period average) in Austria in 1988 to that in 1992?
Provide a short and direct response. 1.12. What is the ratio of the Official exchange rate (LCU per US$ period average) of Brunei Darussalam in 1988 to that in 1992?
Ensure brevity in your answer.  1.24. What is the ratio of the Official exchange rate (LCU per US$ period average) of Guyana in 1988 to that in 1992?
Your response must be concise. 0.08. What is the ratio of the Official exchange rate (LCU per US$ period average) in Austria in 1988 to that in 1993?
Your answer should be compact. 1.06. What is the ratio of the Official exchange rate (LCU per US$ period average) of Brunei Darussalam in 1988 to that in 1993?
Your answer should be very brief. 1.25. What is the ratio of the Official exchange rate (LCU per US$ period average) in Guyana in 1988 to that in 1993?
Keep it short and to the point. 0.08. What is the ratio of the Official exchange rate (LCU per US$ period average) in Austria in 1989 to that in 1990?
Keep it short and to the point. 1.16. What is the ratio of the Official exchange rate (LCU per US$ period average) in Brunei Darussalam in 1989 to that in 1990?
Your answer should be compact. 1.08. What is the ratio of the Official exchange rate (LCU per US$ period average) in Guyana in 1989 to that in 1990?
Offer a very short reply. 0.69. What is the ratio of the Official exchange rate (LCU per US$ period average) of Austria in 1989 to that in 1991?
Offer a terse response. 1.13. What is the ratio of the Official exchange rate (LCU per US$ period average) in Brunei Darussalam in 1989 to that in 1991?
Offer a terse response. 1.13. What is the ratio of the Official exchange rate (LCU per US$ period average) in Guyana in 1989 to that in 1991?
Provide a succinct answer. 0.24. What is the ratio of the Official exchange rate (LCU per US$ period average) of Austria in 1989 to that in 1992?
Make the answer very short. 1.2. What is the ratio of the Official exchange rate (LCU per US$ period average) of Brunei Darussalam in 1989 to that in 1992?
Your answer should be very brief. 1.2. What is the ratio of the Official exchange rate (LCU per US$ period average) of Guyana in 1989 to that in 1992?
Your response must be concise. 0.22. What is the ratio of the Official exchange rate (LCU per US$ period average) in Austria in 1989 to that in 1993?
Your response must be concise. 1.14. What is the ratio of the Official exchange rate (LCU per US$ period average) of Brunei Darussalam in 1989 to that in 1993?
Your answer should be compact. 1.21. What is the ratio of the Official exchange rate (LCU per US$ period average) in Guyana in 1989 to that in 1993?
Your answer should be compact. 0.21. What is the ratio of the Official exchange rate (LCU per US$ period average) of Austria in 1990 to that in 1991?
Ensure brevity in your answer.  0.97. What is the ratio of the Official exchange rate (LCU per US$ period average) of Brunei Darussalam in 1990 to that in 1991?
Keep it short and to the point. 1.05. What is the ratio of the Official exchange rate (LCU per US$ period average) of Guyana in 1990 to that in 1991?
Ensure brevity in your answer.  0.35. What is the ratio of the Official exchange rate (LCU per US$ period average) of Austria in 1990 to that in 1992?
Offer a terse response. 1.03. What is the ratio of the Official exchange rate (LCU per US$ period average) of Brunei Darussalam in 1990 to that in 1992?
Offer a very short reply. 1.11. What is the ratio of the Official exchange rate (LCU per US$ period average) in Guyana in 1990 to that in 1992?
Offer a terse response. 0.32. What is the ratio of the Official exchange rate (LCU per US$ period average) of Austria in 1990 to that in 1993?
Keep it short and to the point. 0.98. What is the ratio of the Official exchange rate (LCU per US$ period average) in Brunei Darussalam in 1990 to that in 1993?
Your response must be concise. 1.12. What is the ratio of the Official exchange rate (LCU per US$ period average) of Guyana in 1990 to that in 1993?
Keep it short and to the point. 0.31. What is the ratio of the Official exchange rate (LCU per US$ period average) in Brunei Darussalam in 1991 to that in 1992?
Make the answer very short. 1.06. What is the ratio of the Official exchange rate (LCU per US$ period average) of Guyana in 1991 to that in 1992?
Offer a terse response. 0.89. What is the ratio of the Official exchange rate (LCU per US$ period average) of Brunei Darussalam in 1991 to that in 1993?
Your answer should be compact. 1.07. What is the ratio of the Official exchange rate (LCU per US$ period average) in Guyana in 1991 to that in 1993?
Your answer should be compact. 0.88. What is the ratio of the Official exchange rate (LCU per US$ period average) of Austria in 1992 to that in 1993?
Provide a short and direct response. 0.94. What is the ratio of the Official exchange rate (LCU per US$ period average) in Brunei Darussalam in 1992 to that in 1993?
Ensure brevity in your answer.  1.01. What is the ratio of the Official exchange rate (LCU per US$ period average) of Guyana in 1992 to that in 1993?
Give a very brief answer. 0.99. What is the difference between the highest and the second highest Official exchange rate (LCU per US$ period average) of Austria?
Your response must be concise. 2.04. What is the difference between the highest and the second highest Official exchange rate (LCU per US$ period average) in Brunei Darussalam?
Your answer should be very brief. 0.07. What is the difference between the highest and the second highest Official exchange rate (LCU per US$ period average) in Guyana?
Provide a succinct answer. 1.73. What is the difference between the highest and the lowest Official exchange rate (LCU per US$ period average) of Austria?
Keep it short and to the point. 4.28. What is the difference between the highest and the lowest Official exchange rate (LCU per US$ period average) in Brunei Darussalam?
Keep it short and to the point. 0.56. What is the difference between the highest and the lowest Official exchange rate (LCU per US$ period average) in Guyana?
Provide a short and direct response. 122.46. 